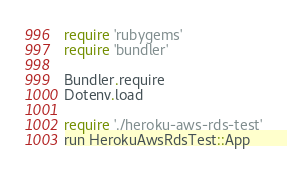<code> <loc_0><loc_0><loc_500><loc_500><_Ruby_>require 'rubygems'
require 'bundler'

Bundler.require
Dotenv.load

require './heroku-aws-rds-test'
run HerokuAwsRdsTest::App
</code> 